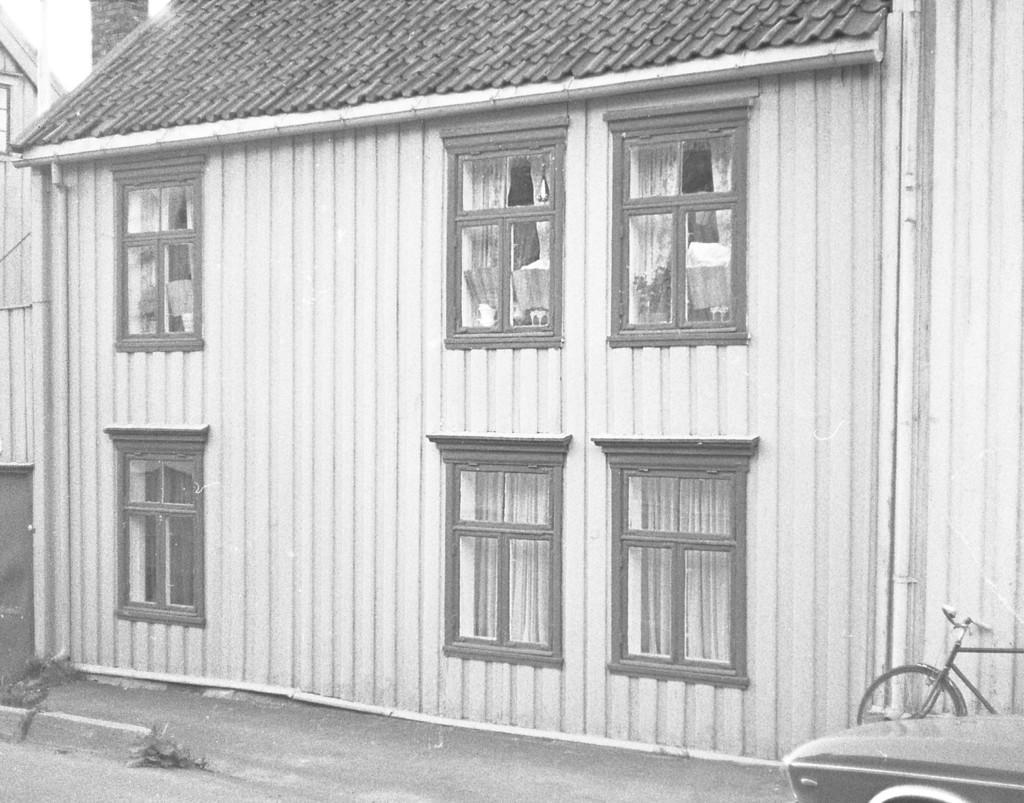Can you describe this image briefly? In this image there is a house. There are windows. To the right side of the image there is a bicycle and a car. 